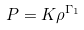Convert formula to latex. <formula><loc_0><loc_0><loc_500><loc_500>P = K \rho ^ { \Gamma _ { 1 } }</formula> 